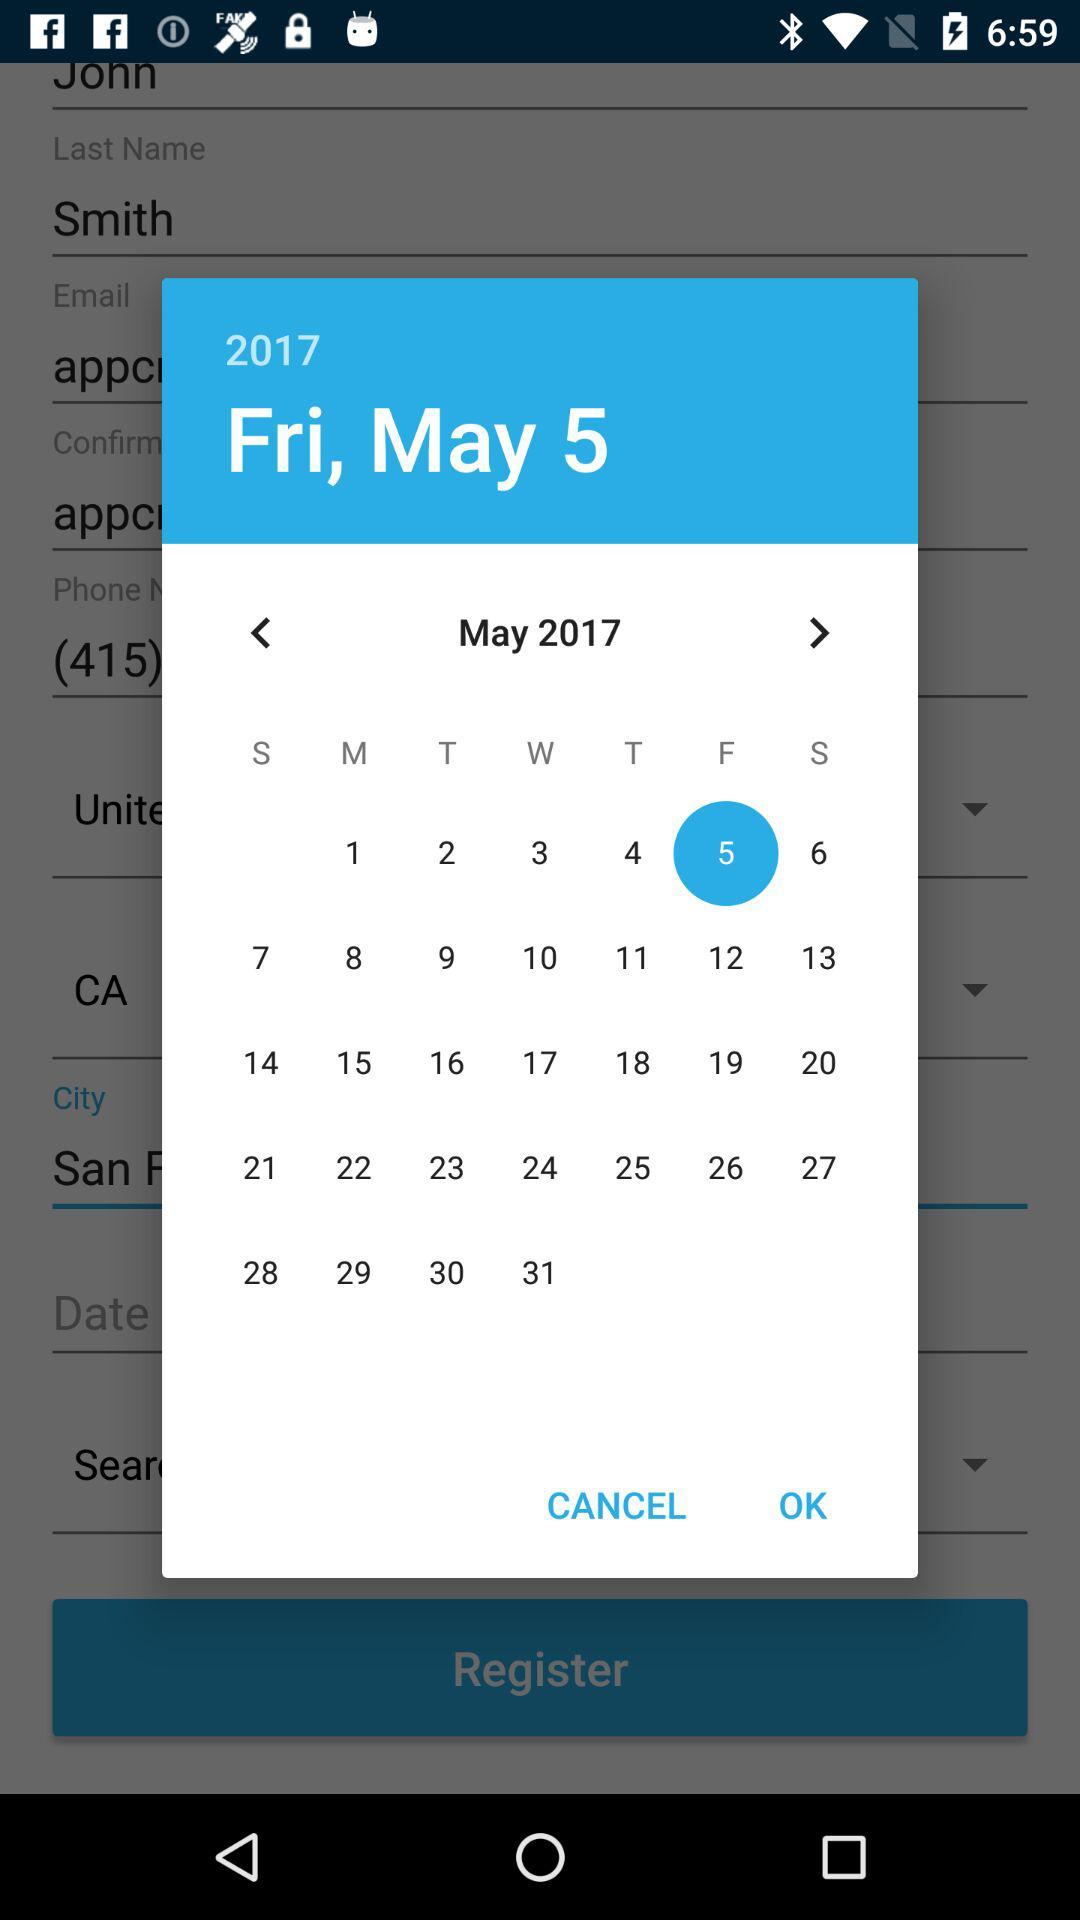What is the selected date? The selected date is Friday, 5th May, 2017. 